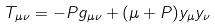<formula> <loc_0><loc_0><loc_500><loc_500>T _ { \mu \nu } = - P g _ { \mu \nu } + ( \mu + P ) y _ { \mu } y _ { \nu }</formula> 